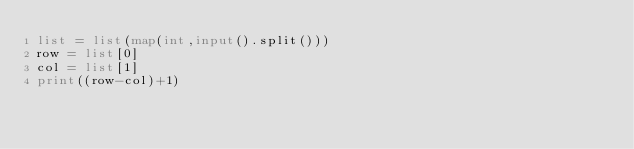Convert code to text. <code><loc_0><loc_0><loc_500><loc_500><_Python_>list = list(map(int,input().split()))
row = list[0]
col = list[1]
print((row-col)+1)</code> 